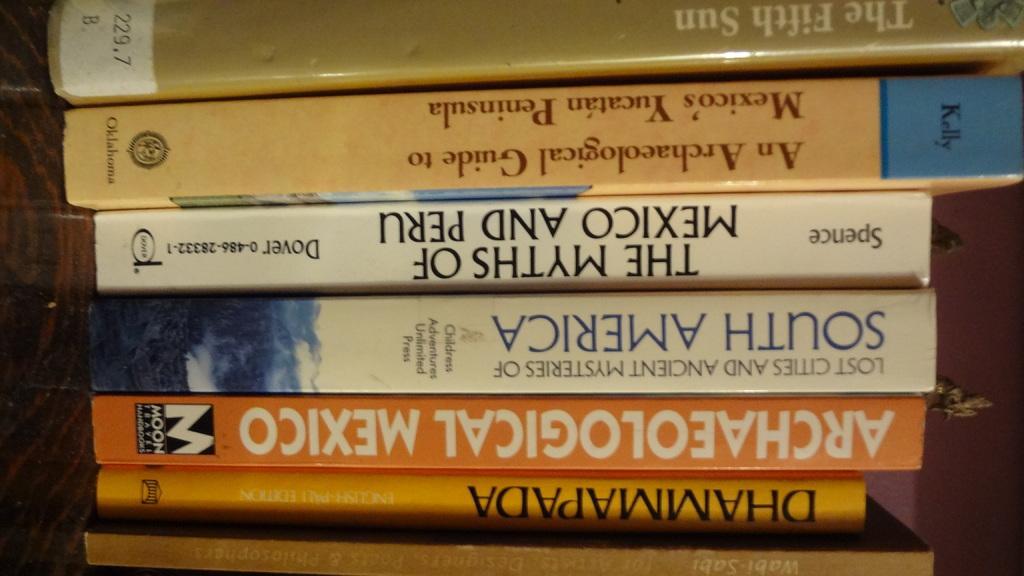Describe this image in one or two sentences. In this picture we can see books, here we can see a wooden object and a wall. 